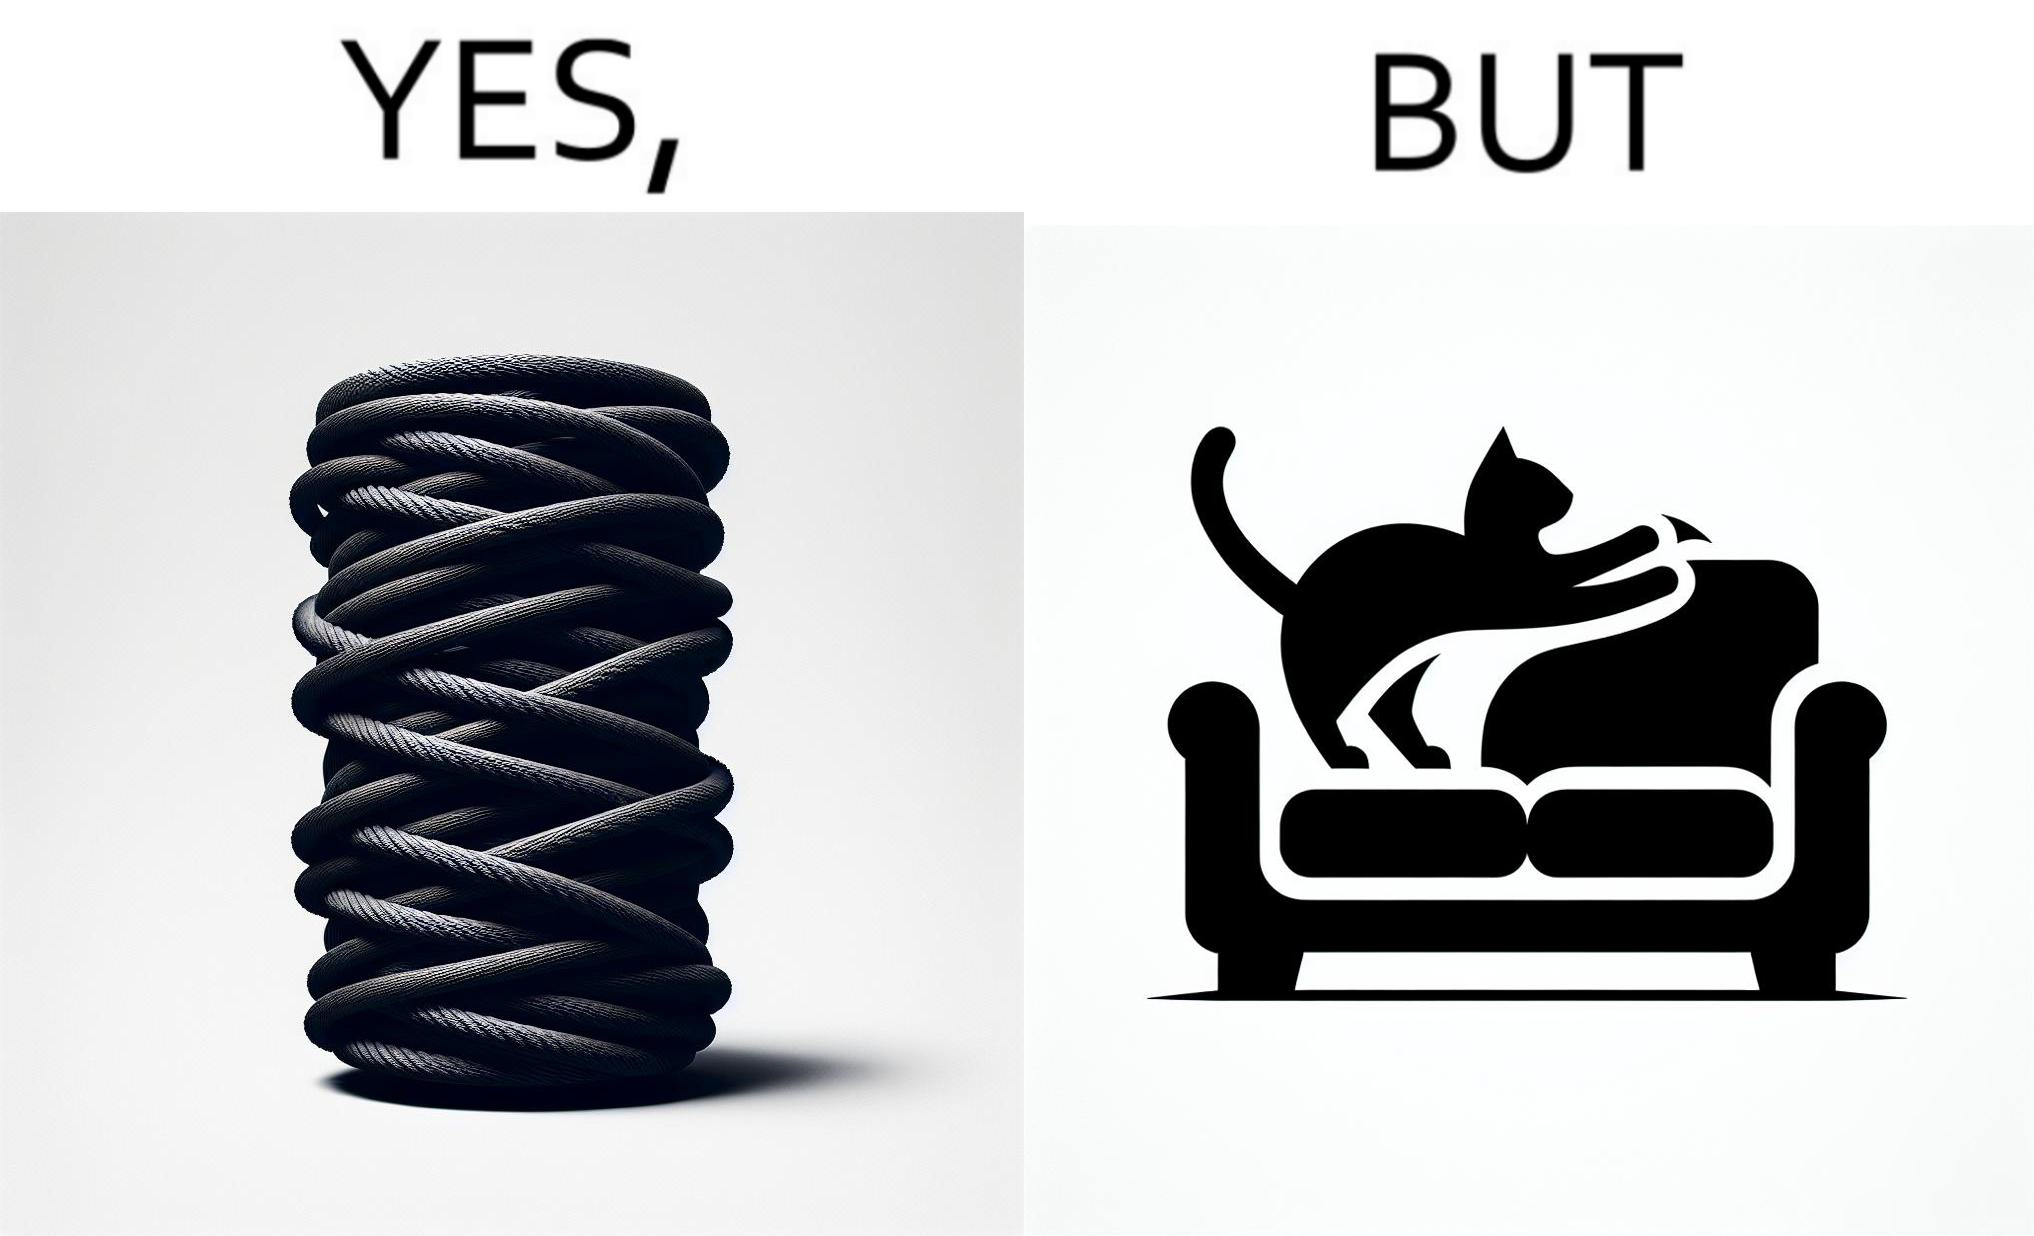Describe what you see in the left and right parts of this image. In the left part of the image: a cylindrical toy or some sort of thing  with a lots of rope wounded around its surface In the right part of the image: a cat scratching its nails over the sides of a sofa or trying to climb up the sofa 